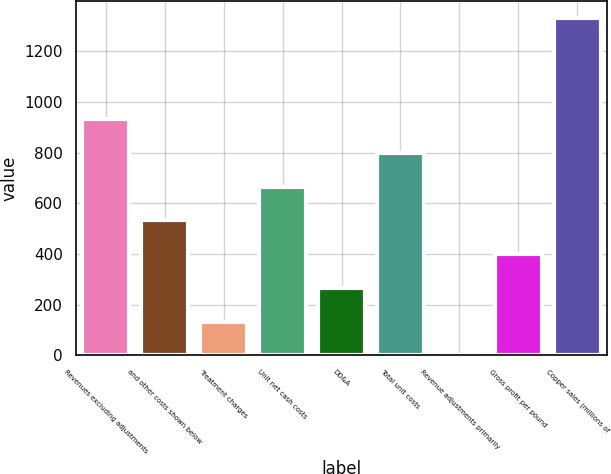<chart> <loc_0><loc_0><loc_500><loc_500><bar_chart><fcel>Revenues excluding adjustments<fcel>and other costs shown below<fcel>Treatment charges<fcel>Unit net cash costs<fcel>DD&A<fcel>Total unit costs<fcel>Revenue adjustments primarily<fcel>Gross profit per pound<fcel>Copper sales (millions of<nl><fcel>932.41<fcel>532.81<fcel>133.21<fcel>666.01<fcel>266.41<fcel>799.21<fcel>0.01<fcel>399.61<fcel>1332<nl></chart> 